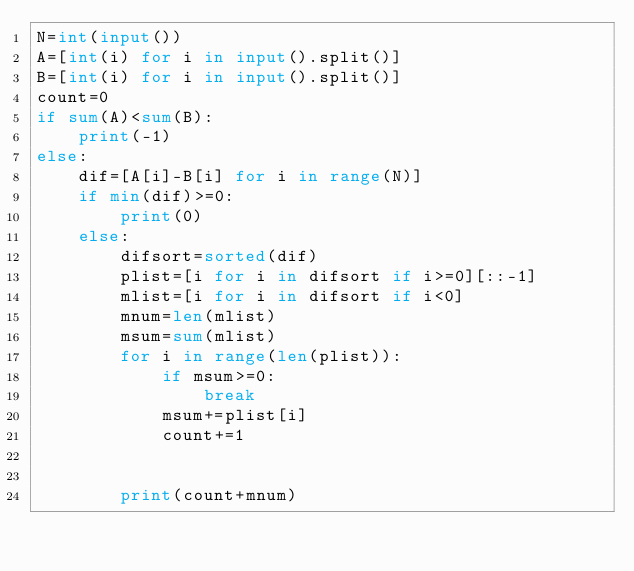Convert code to text. <code><loc_0><loc_0><loc_500><loc_500><_Python_>N=int(input())
A=[int(i) for i in input().split()]
B=[int(i) for i in input().split()]
count=0
if sum(A)<sum(B):
    print(-1)
else:
    dif=[A[i]-B[i] for i in range(N)]
    if min(dif)>=0:
        print(0)
    else:
        difsort=sorted(dif)
        plist=[i for i in difsort if i>=0][::-1]
        mlist=[i for i in difsort if i<0]
        mnum=len(mlist)
        msum=sum(mlist)
        for i in range(len(plist)):
            if msum>=0:
                break
            msum+=plist[i]
            count+=1
            
        
        print(count+mnum)</code> 